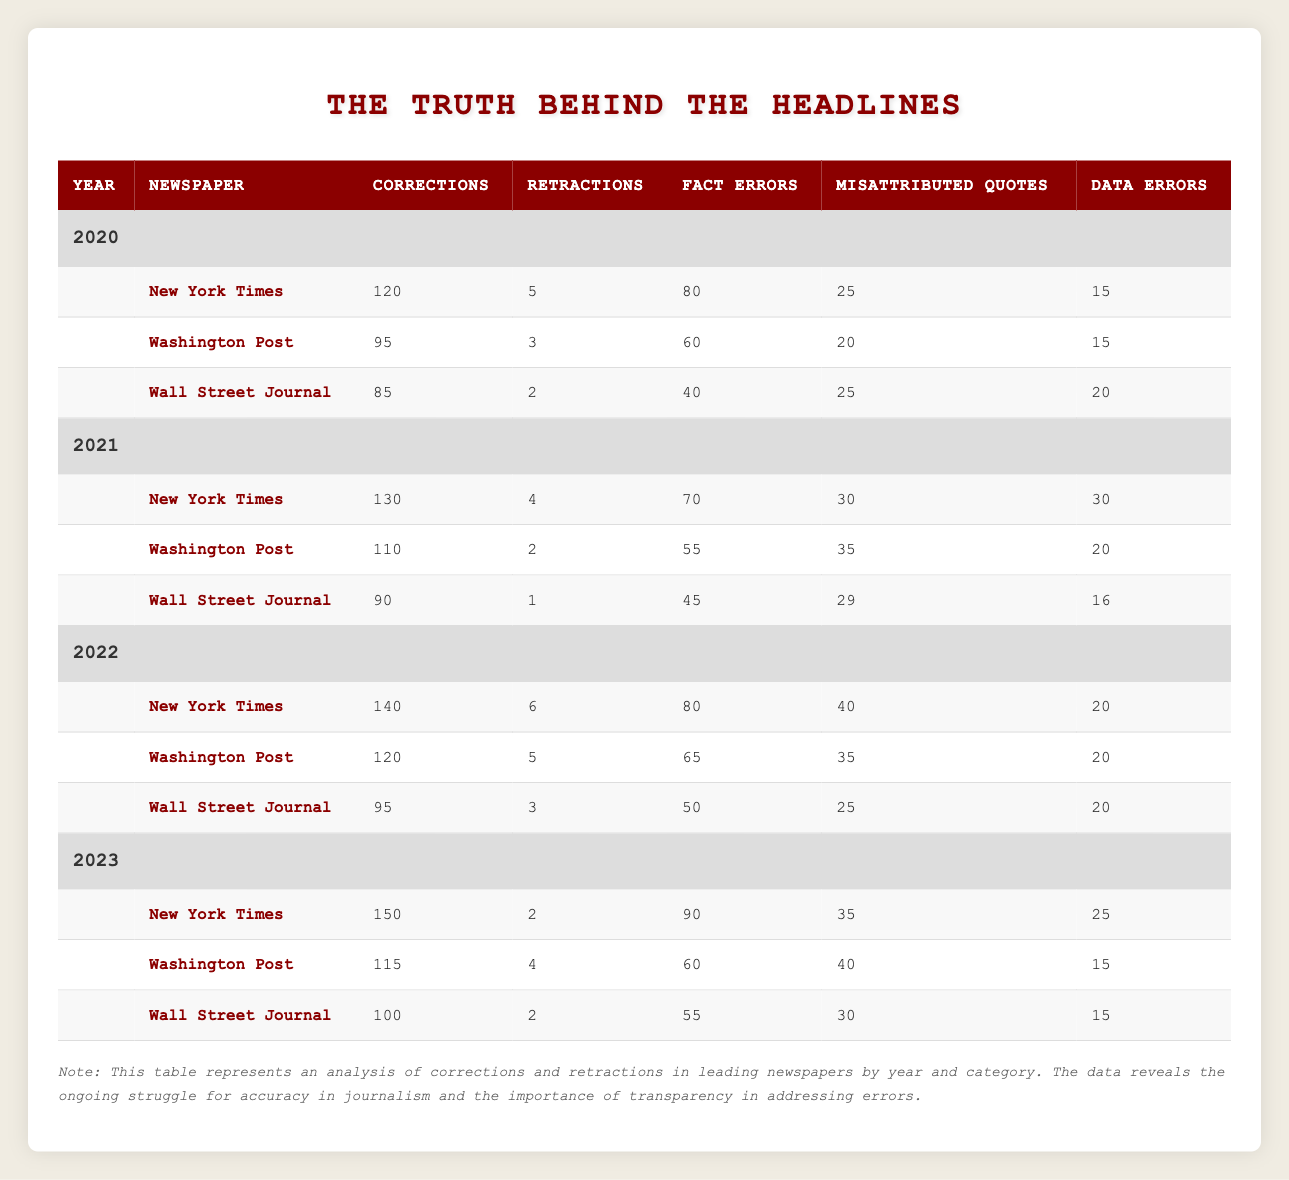What is the total number of corrections made by the New York Times in 2020? The New York Times reported 120 corrections in 2020 as seen in the table under the corresponding year and newspaper columns.
Answer: 120 How many retractions did the Wall Street Journal have in 2022? In 2022, the Wall Street Journal had 3 retractions according to the data provided in the table for that specific year and newspaper.
Answer: 3 What is the difference in the number of corrections between the New York Times in 2021 and 2022? The New York Times had 130 corrections in 2021 and 140 corrections in 2022. The difference is calculated as 140 - 130 = 10.
Answer: 10 Did the Washington Post have more corrections in 2022 than in 2021? The Washington Post had 120 corrections in 2022 and 110 corrections in 2021, therefore, 120 is greater than 110, so the statement is true.
Answer: Yes Calculate the average number of retractions made by the Wall Street Journal over the four years from 2020 to 2023. The Wall Street Journal reported retractions as follows: 2 in 2020, 1 in 2021, 3 in 2022, and 2 in 2023. The total is 2 + 1 + 3 + 2 = 8, and there are 4 years, thus the average is 8 / 4 = 2.
Answer: 2 In which year did the New York Times have the highest number of fact errors? The New York Times had the following fact errors: 80 in 2020, 70 in 2021, 80 in 2022, and 90 in 2023. The highest number is 90 in 2023.
Answer: 2023 Which newspaper recorded the least number of corrections in 2021? The Wall Street Journal recorded 90 corrections in 2021, fewer than the New York Times with 130 and the Washington Post with 110. Therefore, it had the least.
Answer: Wall Street Journal How many total corrections were made by the Washington Post from 2020 to 2023? The Washington Post had 95 corrections in 2020, 110 in 2021, 120 in 2022, and 115 in 2023. Adding these values gives 95 + 110 + 120 + 115 = 440 corrections in total.
Answer: 440 True or False: The number of corrections for the Wall Street Journal decreased from 2020 to 2021. The Wall Street Journal had 85 corrections in 2020 and 90 in 2021, indicating an increase rather than a decrease. Therefore, the statement is false.
Answer: False 